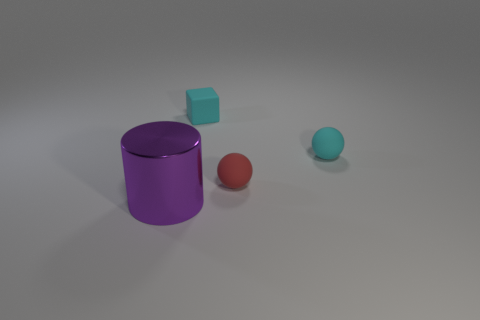There is a tiny matte ball in front of the tiny cyan object that is to the right of the tiny cube behind the cyan matte sphere; what is its color?
Provide a short and direct response. Red. Do the large thing and the tiny ball on the right side of the red matte ball have the same material?
Provide a short and direct response. No. Are there the same number of tiny spheres that are in front of the metal thing and rubber balls that are on the left side of the tiny cyan matte block?
Your answer should be compact. Yes. What number of other objects are there of the same material as the cyan sphere?
Ensure brevity in your answer.  2. Are there an equal number of purple metallic objects behind the tiny cyan rubber block and small green rubber blocks?
Your answer should be compact. Yes. Do the red ball and the matte object to the right of the tiny red rubber object have the same size?
Your response must be concise. Yes. The thing that is on the left side of the small cyan rubber block has what shape?
Offer a very short reply. Cylinder. Is there anything else that is the same shape as the shiny object?
Offer a terse response. No. Is there a yellow cylinder?
Your response must be concise. No. There is a cyan thing right of the tiny cyan rubber cube; does it have the same size as the object that is left of the cyan block?
Offer a very short reply. No. 